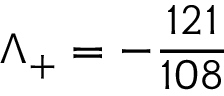Convert formula to latex. <formula><loc_0><loc_0><loc_500><loc_500>\Lambda _ { + } = - \frac { 1 2 1 } { 1 0 8 }</formula> 